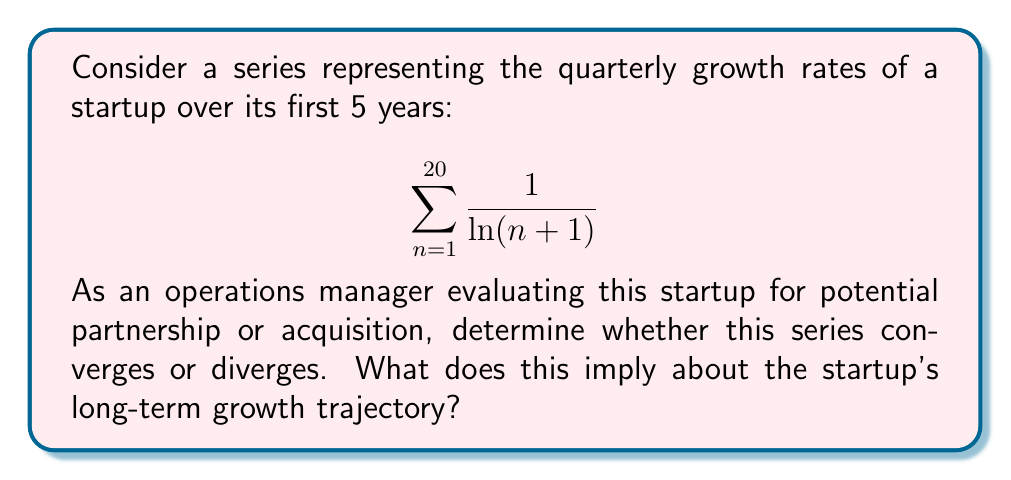Can you solve this math problem? To analyze the convergence of this series, we'll use the integral test. This test is appropriate because the function $f(x) = \frac{1}{\ln(x+1)}$ is positive and decreasing for $x \geq 1$.

1) First, let's set up the improper integral:

   $$\int_{1}^{\infty} \frac{1}{\ln(x+1)} dx$$

2) To evaluate this integral, we'll use the substitution $u = \ln(x+1)$. Then:
   
   $du = \frac{1}{x+1} dx$
   $dx = (x+1) du = e^u du$

3) Substituting these into our integral:

   $$\int_{1}^{\infty} \frac{1}{\ln(x+1)} dx = \int_{\ln 2}^{\infty} \frac{e^u}{u} du$$

4) This integral is of the form $\int \frac{e^u}{u} du$, which doesn't have an elementary antiderivative. However, we can compare it to the integral of $e^u$:

   $$\int_{\ln 2}^{\infty} e^u du = [e^u]_{\ln 2}^{\infty} = \infty - 2 = \infty$$

5) Since $\frac{e^u}{u} > e^u$ for large $u$, we can conclude that:

   $$\int_{\ln 2}^{\infty} \frac{e^u}{u} du > \int_{\ln 2}^{\infty} e^u du = \infty$$

6) Therefore, the improper integral diverges, which means the original series also diverges.

From a business perspective, this divergence suggests that the startup's quarterly growth rates, while decreasing over time (as $\frac{1}{\ln(n+1)}$ decreases as $n$ increases), are not decreasing fast enough to result in a convergent total growth. This could indicate a startup with strong, sustained growth potential, making it an attractive candidate for partnership or acquisition. However, it's important to note that this mathematical model assumes indefinite growth, which may not be realistic in practice due to market saturation and other limiting factors.
Answer: The series diverges, implying potentially strong, sustained growth for the startup, but with the caveat that indefinite growth is unrealistic in practice. 